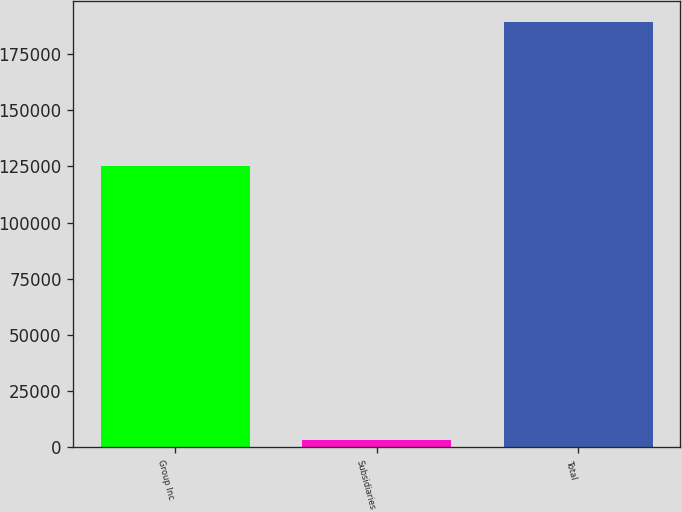<chart> <loc_0><loc_0><loc_500><loc_500><bar_chart><fcel>Group Inc<fcel>Subsidiaries<fcel>Total<nl><fcel>125159<fcel>3113<fcel>189086<nl></chart> 